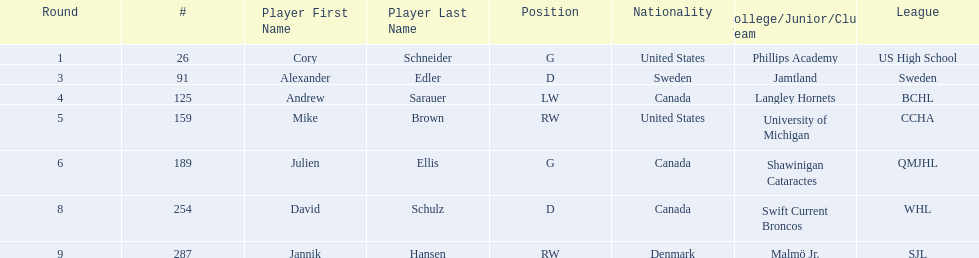How many players are from the united states? 2. 